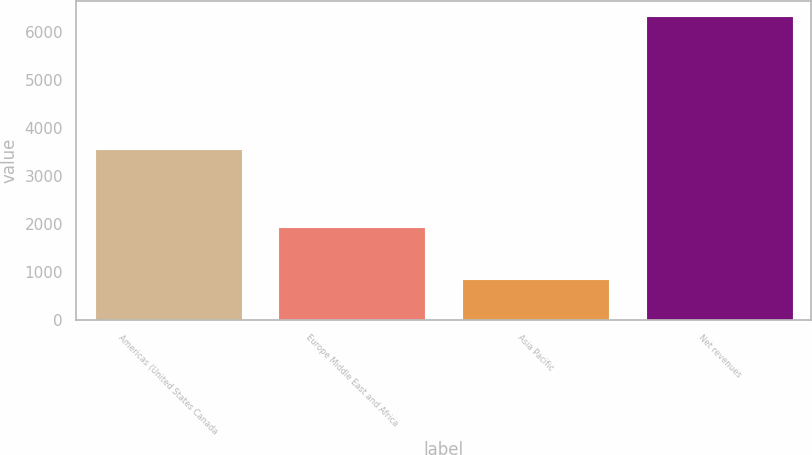Convert chart to OTSL. <chart><loc_0><loc_0><loc_500><loc_500><bar_chart><fcel>Americas (United States Canada<fcel>Europe Middle East and Africa<fcel>Asia Pacific<fcel>Net revenues<nl><fcel>3552.5<fcel>1928.8<fcel>851.1<fcel>6332.4<nl></chart> 